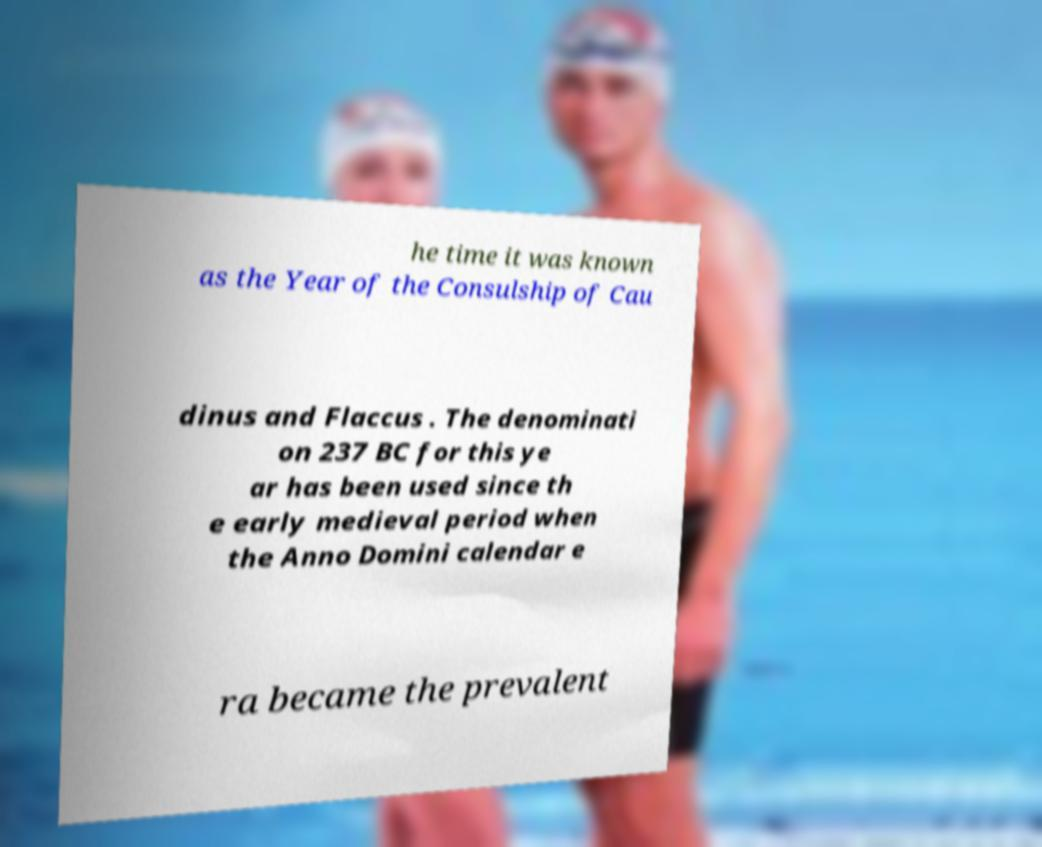What messages or text are displayed in this image? I need them in a readable, typed format. he time it was known as the Year of the Consulship of Cau dinus and Flaccus . The denominati on 237 BC for this ye ar has been used since th e early medieval period when the Anno Domini calendar e ra became the prevalent 